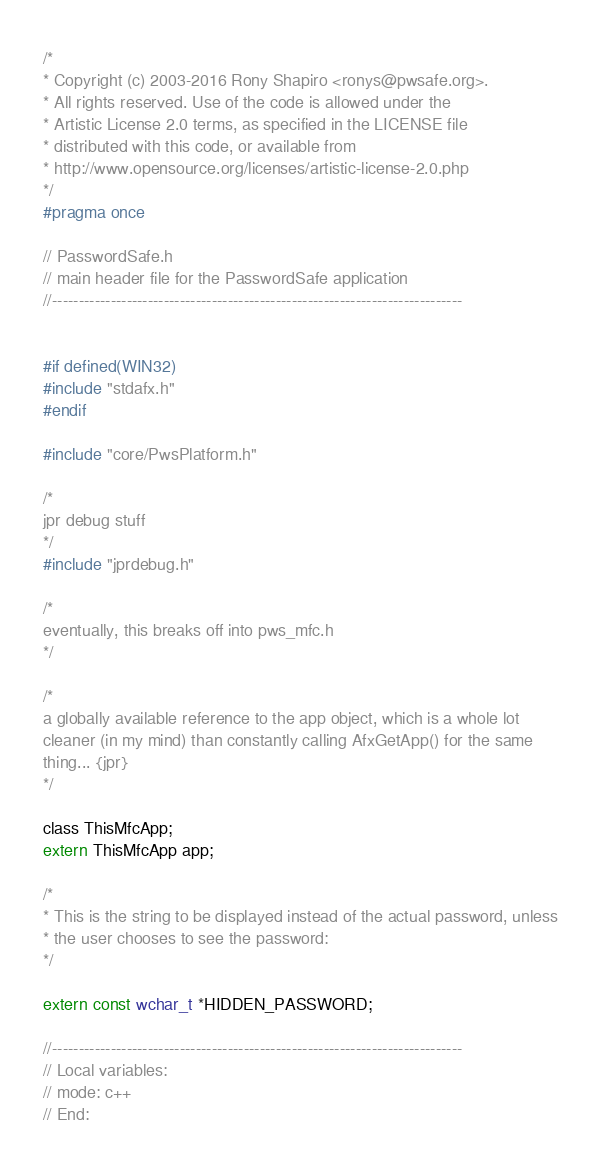Convert code to text. <code><loc_0><loc_0><loc_500><loc_500><_C_>/*
* Copyright (c) 2003-2016 Rony Shapiro <ronys@pwsafe.org>.
* All rights reserved. Use of the code is allowed under the
* Artistic License 2.0 terms, as specified in the LICENSE file
* distributed with this code, or available from
* http://www.opensource.org/licenses/artistic-license-2.0.php
*/
#pragma once

// PasswordSafe.h
// main header file for the PasswordSafe application
//-----------------------------------------------------------------------------


#if defined(WIN32)
#include "stdafx.h"
#endif

#include "core/PwsPlatform.h"

/*
jpr debug stuff
*/
#include "jprdebug.h"

/*
eventually, this breaks off into pws_mfc.h
*/

/*
a globally available reference to the app object, which is a whole lot
cleaner (in my mind) than constantly calling AfxGetApp() for the same
thing... {jpr}
*/

class ThisMfcApp;
extern ThisMfcApp app;

/*
* This is the string to be displayed instead of the actual password, unless
* the user chooses to see the password:
*/

extern const wchar_t *HIDDEN_PASSWORD;

//-----------------------------------------------------------------------------
// Local variables:
// mode: c++
// End:
</code> 